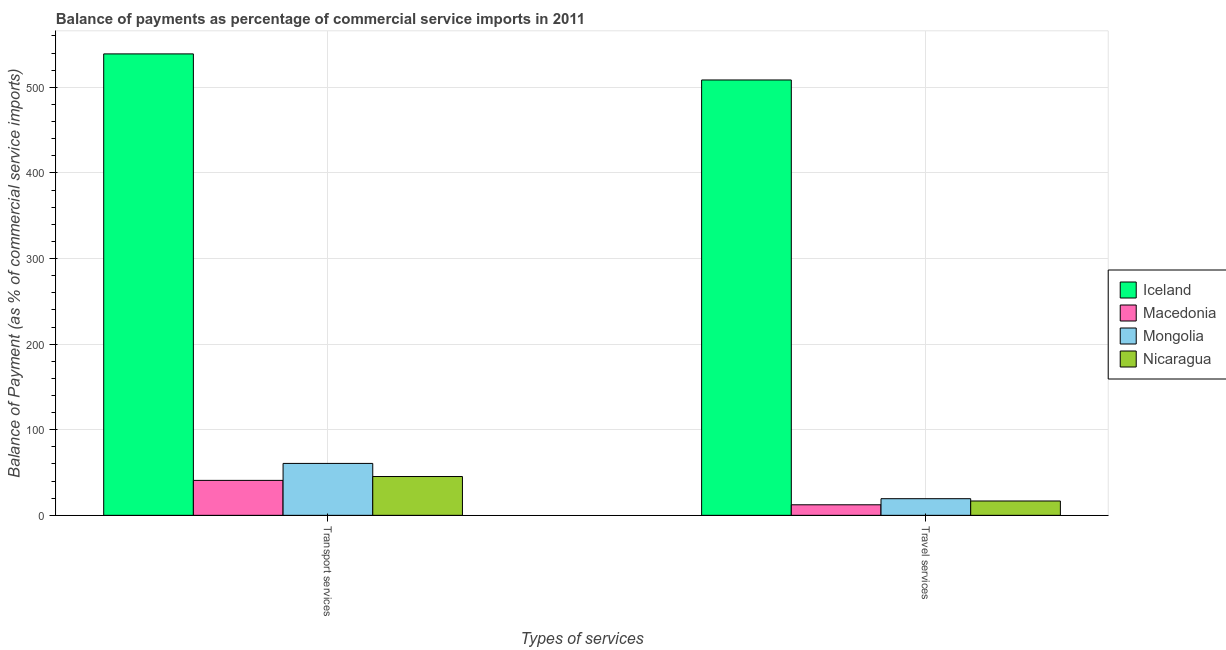How many different coloured bars are there?
Offer a terse response. 4. How many groups of bars are there?
Provide a short and direct response. 2. Are the number of bars per tick equal to the number of legend labels?
Offer a terse response. Yes. Are the number of bars on each tick of the X-axis equal?
Offer a very short reply. Yes. How many bars are there on the 1st tick from the left?
Ensure brevity in your answer.  4. What is the label of the 1st group of bars from the left?
Make the answer very short. Transport services. What is the balance of payments of transport services in Mongolia?
Keep it short and to the point. 60.66. Across all countries, what is the maximum balance of payments of transport services?
Keep it short and to the point. 539.07. Across all countries, what is the minimum balance of payments of transport services?
Offer a terse response. 40.84. In which country was the balance of payments of travel services minimum?
Keep it short and to the point. Macedonia. What is the total balance of payments of transport services in the graph?
Keep it short and to the point. 685.92. What is the difference between the balance of payments of transport services in Macedonia and that in Nicaragua?
Offer a very short reply. -4.51. What is the difference between the balance of payments of transport services in Mongolia and the balance of payments of travel services in Iceland?
Keep it short and to the point. -447.95. What is the average balance of payments of travel services per country?
Keep it short and to the point. 139.29. What is the difference between the balance of payments of transport services and balance of payments of travel services in Macedonia?
Offer a very short reply. 28.52. What is the ratio of the balance of payments of travel services in Iceland to that in Macedonia?
Give a very brief answer. 41.28. Is the balance of payments of transport services in Macedonia less than that in Mongolia?
Provide a short and direct response. Yes. In how many countries, is the balance of payments of travel services greater than the average balance of payments of travel services taken over all countries?
Provide a succinct answer. 1. What does the 4th bar from the left in Travel services represents?
Offer a terse response. Nicaragua. What does the 4th bar from the right in Travel services represents?
Keep it short and to the point. Iceland. How many bars are there?
Ensure brevity in your answer.  8. Are all the bars in the graph horizontal?
Your response must be concise. No. Are the values on the major ticks of Y-axis written in scientific E-notation?
Ensure brevity in your answer.  No. Where does the legend appear in the graph?
Provide a short and direct response. Center right. What is the title of the graph?
Give a very brief answer. Balance of payments as percentage of commercial service imports in 2011. What is the label or title of the X-axis?
Provide a short and direct response. Types of services. What is the label or title of the Y-axis?
Offer a terse response. Balance of Payment (as % of commercial service imports). What is the Balance of Payment (as % of commercial service imports) of Iceland in Transport services?
Ensure brevity in your answer.  539.07. What is the Balance of Payment (as % of commercial service imports) of Macedonia in Transport services?
Give a very brief answer. 40.84. What is the Balance of Payment (as % of commercial service imports) in Mongolia in Transport services?
Your response must be concise. 60.66. What is the Balance of Payment (as % of commercial service imports) of Nicaragua in Transport services?
Offer a terse response. 45.35. What is the Balance of Payment (as % of commercial service imports) in Iceland in Travel services?
Your answer should be very brief. 508.61. What is the Balance of Payment (as % of commercial service imports) in Macedonia in Travel services?
Offer a terse response. 12.32. What is the Balance of Payment (as % of commercial service imports) of Mongolia in Travel services?
Keep it short and to the point. 19.45. What is the Balance of Payment (as % of commercial service imports) of Nicaragua in Travel services?
Your answer should be very brief. 16.76. Across all Types of services, what is the maximum Balance of Payment (as % of commercial service imports) in Iceland?
Your answer should be compact. 539.07. Across all Types of services, what is the maximum Balance of Payment (as % of commercial service imports) of Macedonia?
Provide a short and direct response. 40.84. Across all Types of services, what is the maximum Balance of Payment (as % of commercial service imports) in Mongolia?
Provide a succinct answer. 60.66. Across all Types of services, what is the maximum Balance of Payment (as % of commercial service imports) in Nicaragua?
Keep it short and to the point. 45.35. Across all Types of services, what is the minimum Balance of Payment (as % of commercial service imports) of Iceland?
Your response must be concise. 508.61. Across all Types of services, what is the minimum Balance of Payment (as % of commercial service imports) in Macedonia?
Offer a terse response. 12.32. Across all Types of services, what is the minimum Balance of Payment (as % of commercial service imports) in Mongolia?
Your answer should be very brief. 19.45. Across all Types of services, what is the minimum Balance of Payment (as % of commercial service imports) of Nicaragua?
Make the answer very short. 16.76. What is the total Balance of Payment (as % of commercial service imports) in Iceland in the graph?
Provide a succinct answer. 1047.68. What is the total Balance of Payment (as % of commercial service imports) in Macedonia in the graph?
Offer a terse response. 53.16. What is the total Balance of Payment (as % of commercial service imports) of Mongolia in the graph?
Offer a very short reply. 80.11. What is the total Balance of Payment (as % of commercial service imports) of Nicaragua in the graph?
Provide a short and direct response. 62.11. What is the difference between the Balance of Payment (as % of commercial service imports) of Iceland in Transport services and that in Travel services?
Give a very brief answer. 30.46. What is the difference between the Balance of Payment (as % of commercial service imports) of Macedonia in Transport services and that in Travel services?
Keep it short and to the point. 28.52. What is the difference between the Balance of Payment (as % of commercial service imports) of Mongolia in Transport services and that in Travel services?
Your response must be concise. 41.2. What is the difference between the Balance of Payment (as % of commercial service imports) in Nicaragua in Transport services and that in Travel services?
Your answer should be very brief. 28.59. What is the difference between the Balance of Payment (as % of commercial service imports) in Iceland in Transport services and the Balance of Payment (as % of commercial service imports) in Macedonia in Travel services?
Ensure brevity in your answer.  526.75. What is the difference between the Balance of Payment (as % of commercial service imports) in Iceland in Transport services and the Balance of Payment (as % of commercial service imports) in Mongolia in Travel services?
Ensure brevity in your answer.  519.62. What is the difference between the Balance of Payment (as % of commercial service imports) of Iceland in Transport services and the Balance of Payment (as % of commercial service imports) of Nicaragua in Travel services?
Your answer should be very brief. 522.31. What is the difference between the Balance of Payment (as % of commercial service imports) in Macedonia in Transport services and the Balance of Payment (as % of commercial service imports) in Mongolia in Travel services?
Keep it short and to the point. 21.39. What is the difference between the Balance of Payment (as % of commercial service imports) of Macedonia in Transport services and the Balance of Payment (as % of commercial service imports) of Nicaragua in Travel services?
Provide a short and direct response. 24.08. What is the difference between the Balance of Payment (as % of commercial service imports) in Mongolia in Transport services and the Balance of Payment (as % of commercial service imports) in Nicaragua in Travel services?
Provide a short and direct response. 43.89. What is the average Balance of Payment (as % of commercial service imports) in Iceland per Types of services?
Offer a terse response. 523.84. What is the average Balance of Payment (as % of commercial service imports) in Macedonia per Types of services?
Your answer should be very brief. 26.58. What is the average Balance of Payment (as % of commercial service imports) of Mongolia per Types of services?
Your answer should be very brief. 40.06. What is the average Balance of Payment (as % of commercial service imports) in Nicaragua per Types of services?
Your answer should be compact. 31.06. What is the difference between the Balance of Payment (as % of commercial service imports) in Iceland and Balance of Payment (as % of commercial service imports) in Macedonia in Transport services?
Your answer should be very brief. 498.23. What is the difference between the Balance of Payment (as % of commercial service imports) of Iceland and Balance of Payment (as % of commercial service imports) of Mongolia in Transport services?
Provide a short and direct response. 478.41. What is the difference between the Balance of Payment (as % of commercial service imports) of Iceland and Balance of Payment (as % of commercial service imports) of Nicaragua in Transport services?
Your response must be concise. 493.72. What is the difference between the Balance of Payment (as % of commercial service imports) in Macedonia and Balance of Payment (as % of commercial service imports) in Mongolia in Transport services?
Offer a very short reply. -19.82. What is the difference between the Balance of Payment (as % of commercial service imports) in Macedonia and Balance of Payment (as % of commercial service imports) in Nicaragua in Transport services?
Offer a very short reply. -4.51. What is the difference between the Balance of Payment (as % of commercial service imports) of Mongolia and Balance of Payment (as % of commercial service imports) of Nicaragua in Transport services?
Your answer should be compact. 15.31. What is the difference between the Balance of Payment (as % of commercial service imports) in Iceland and Balance of Payment (as % of commercial service imports) in Macedonia in Travel services?
Ensure brevity in your answer.  496.29. What is the difference between the Balance of Payment (as % of commercial service imports) in Iceland and Balance of Payment (as % of commercial service imports) in Mongolia in Travel services?
Offer a very short reply. 489.16. What is the difference between the Balance of Payment (as % of commercial service imports) in Iceland and Balance of Payment (as % of commercial service imports) in Nicaragua in Travel services?
Offer a very short reply. 491.85. What is the difference between the Balance of Payment (as % of commercial service imports) of Macedonia and Balance of Payment (as % of commercial service imports) of Mongolia in Travel services?
Your answer should be compact. -7.13. What is the difference between the Balance of Payment (as % of commercial service imports) of Macedonia and Balance of Payment (as % of commercial service imports) of Nicaragua in Travel services?
Your answer should be compact. -4.44. What is the difference between the Balance of Payment (as % of commercial service imports) of Mongolia and Balance of Payment (as % of commercial service imports) of Nicaragua in Travel services?
Your answer should be very brief. 2.69. What is the ratio of the Balance of Payment (as % of commercial service imports) in Iceland in Transport services to that in Travel services?
Your response must be concise. 1.06. What is the ratio of the Balance of Payment (as % of commercial service imports) of Macedonia in Transport services to that in Travel services?
Ensure brevity in your answer.  3.32. What is the ratio of the Balance of Payment (as % of commercial service imports) of Mongolia in Transport services to that in Travel services?
Offer a terse response. 3.12. What is the ratio of the Balance of Payment (as % of commercial service imports) of Nicaragua in Transport services to that in Travel services?
Offer a very short reply. 2.71. What is the difference between the highest and the second highest Balance of Payment (as % of commercial service imports) in Iceland?
Ensure brevity in your answer.  30.46. What is the difference between the highest and the second highest Balance of Payment (as % of commercial service imports) in Macedonia?
Provide a succinct answer. 28.52. What is the difference between the highest and the second highest Balance of Payment (as % of commercial service imports) of Mongolia?
Your answer should be very brief. 41.2. What is the difference between the highest and the second highest Balance of Payment (as % of commercial service imports) of Nicaragua?
Your answer should be very brief. 28.59. What is the difference between the highest and the lowest Balance of Payment (as % of commercial service imports) in Iceland?
Your response must be concise. 30.46. What is the difference between the highest and the lowest Balance of Payment (as % of commercial service imports) in Macedonia?
Make the answer very short. 28.52. What is the difference between the highest and the lowest Balance of Payment (as % of commercial service imports) of Mongolia?
Give a very brief answer. 41.2. What is the difference between the highest and the lowest Balance of Payment (as % of commercial service imports) in Nicaragua?
Your response must be concise. 28.59. 